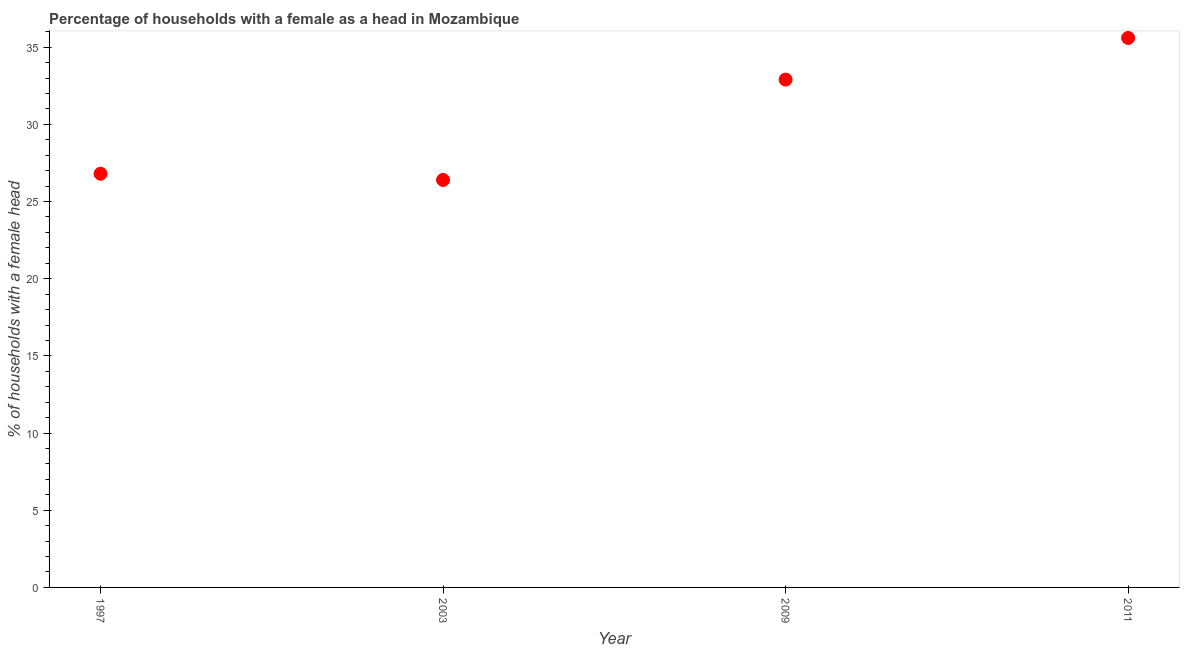What is the number of female supervised households in 2009?
Provide a succinct answer. 32.9. Across all years, what is the maximum number of female supervised households?
Offer a terse response. 35.6. Across all years, what is the minimum number of female supervised households?
Offer a terse response. 26.4. In which year was the number of female supervised households minimum?
Provide a short and direct response. 2003. What is the sum of the number of female supervised households?
Offer a terse response. 121.7. What is the difference between the number of female supervised households in 1997 and 2011?
Give a very brief answer. -8.8. What is the average number of female supervised households per year?
Ensure brevity in your answer.  30.42. What is the median number of female supervised households?
Offer a terse response. 29.85. What is the ratio of the number of female supervised households in 2003 to that in 2009?
Provide a short and direct response. 0.8. Is the number of female supervised households in 2009 less than that in 2011?
Give a very brief answer. Yes. What is the difference between the highest and the second highest number of female supervised households?
Ensure brevity in your answer.  2.7. Is the sum of the number of female supervised households in 2003 and 2009 greater than the maximum number of female supervised households across all years?
Your response must be concise. Yes. What is the difference between the highest and the lowest number of female supervised households?
Your answer should be very brief. 9.2. In how many years, is the number of female supervised households greater than the average number of female supervised households taken over all years?
Your response must be concise. 2. Does the number of female supervised households monotonically increase over the years?
Your response must be concise. No. How many years are there in the graph?
Your response must be concise. 4. What is the difference between two consecutive major ticks on the Y-axis?
Provide a succinct answer. 5. What is the title of the graph?
Give a very brief answer. Percentage of households with a female as a head in Mozambique. What is the label or title of the X-axis?
Your answer should be compact. Year. What is the label or title of the Y-axis?
Make the answer very short. % of households with a female head. What is the % of households with a female head in 1997?
Provide a short and direct response. 26.8. What is the % of households with a female head in 2003?
Provide a short and direct response. 26.4. What is the % of households with a female head in 2009?
Keep it short and to the point. 32.9. What is the % of households with a female head in 2011?
Provide a short and direct response. 35.6. What is the difference between the % of households with a female head in 1997 and 2011?
Your response must be concise. -8.8. What is the difference between the % of households with a female head in 2003 and 2009?
Provide a succinct answer. -6.5. What is the difference between the % of households with a female head in 2003 and 2011?
Your response must be concise. -9.2. What is the difference between the % of households with a female head in 2009 and 2011?
Offer a very short reply. -2.7. What is the ratio of the % of households with a female head in 1997 to that in 2009?
Ensure brevity in your answer.  0.81. What is the ratio of the % of households with a female head in 1997 to that in 2011?
Keep it short and to the point. 0.75. What is the ratio of the % of households with a female head in 2003 to that in 2009?
Your response must be concise. 0.8. What is the ratio of the % of households with a female head in 2003 to that in 2011?
Provide a short and direct response. 0.74. What is the ratio of the % of households with a female head in 2009 to that in 2011?
Give a very brief answer. 0.92. 